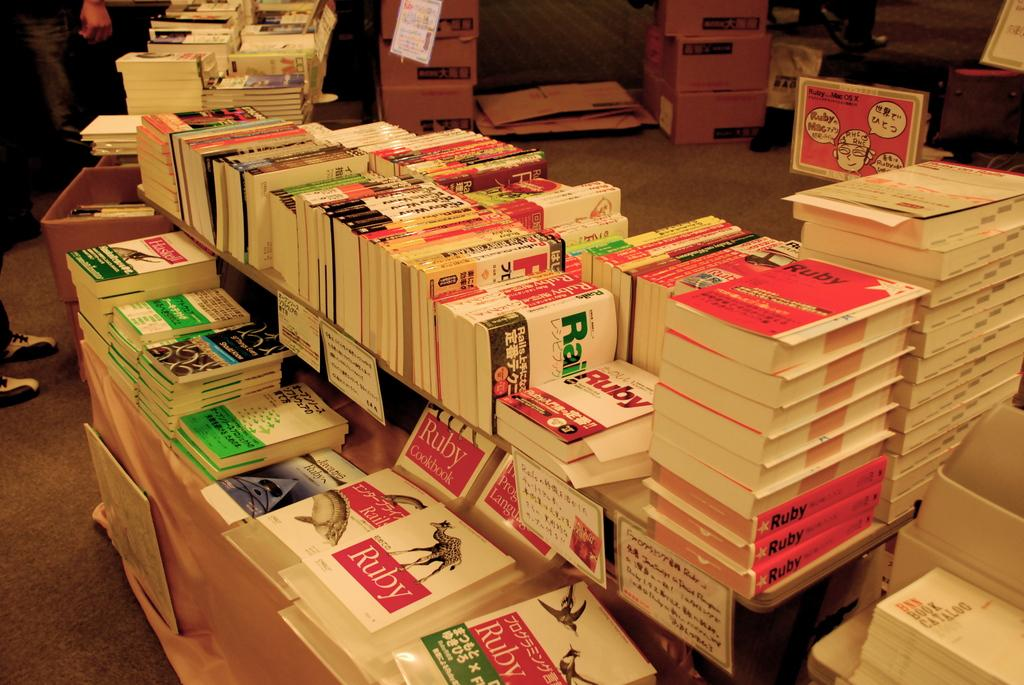<image>
Summarize the visual content of the image. a collection of books saying ruby on the cover 